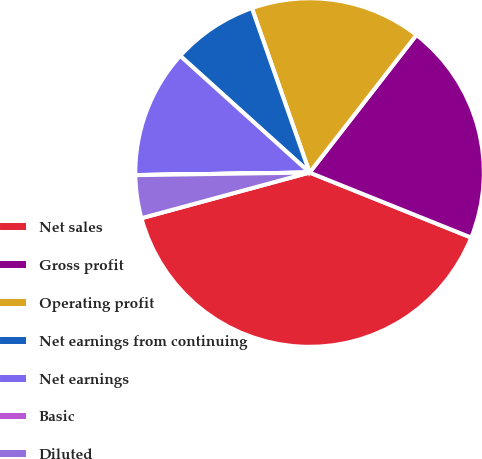<chart> <loc_0><loc_0><loc_500><loc_500><pie_chart><fcel>Net sales<fcel>Gross profit<fcel>Operating profit<fcel>Net earnings from continuing<fcel>Net earnings<fcel>Basic<fcel>Diluted<nl><fcel>39.69%<fcel>20.58%<fcel>15.88%<fcel>7.95%<fcel>11.91%<fcel>0.01%<fcel>3.98%<nl></chart> 